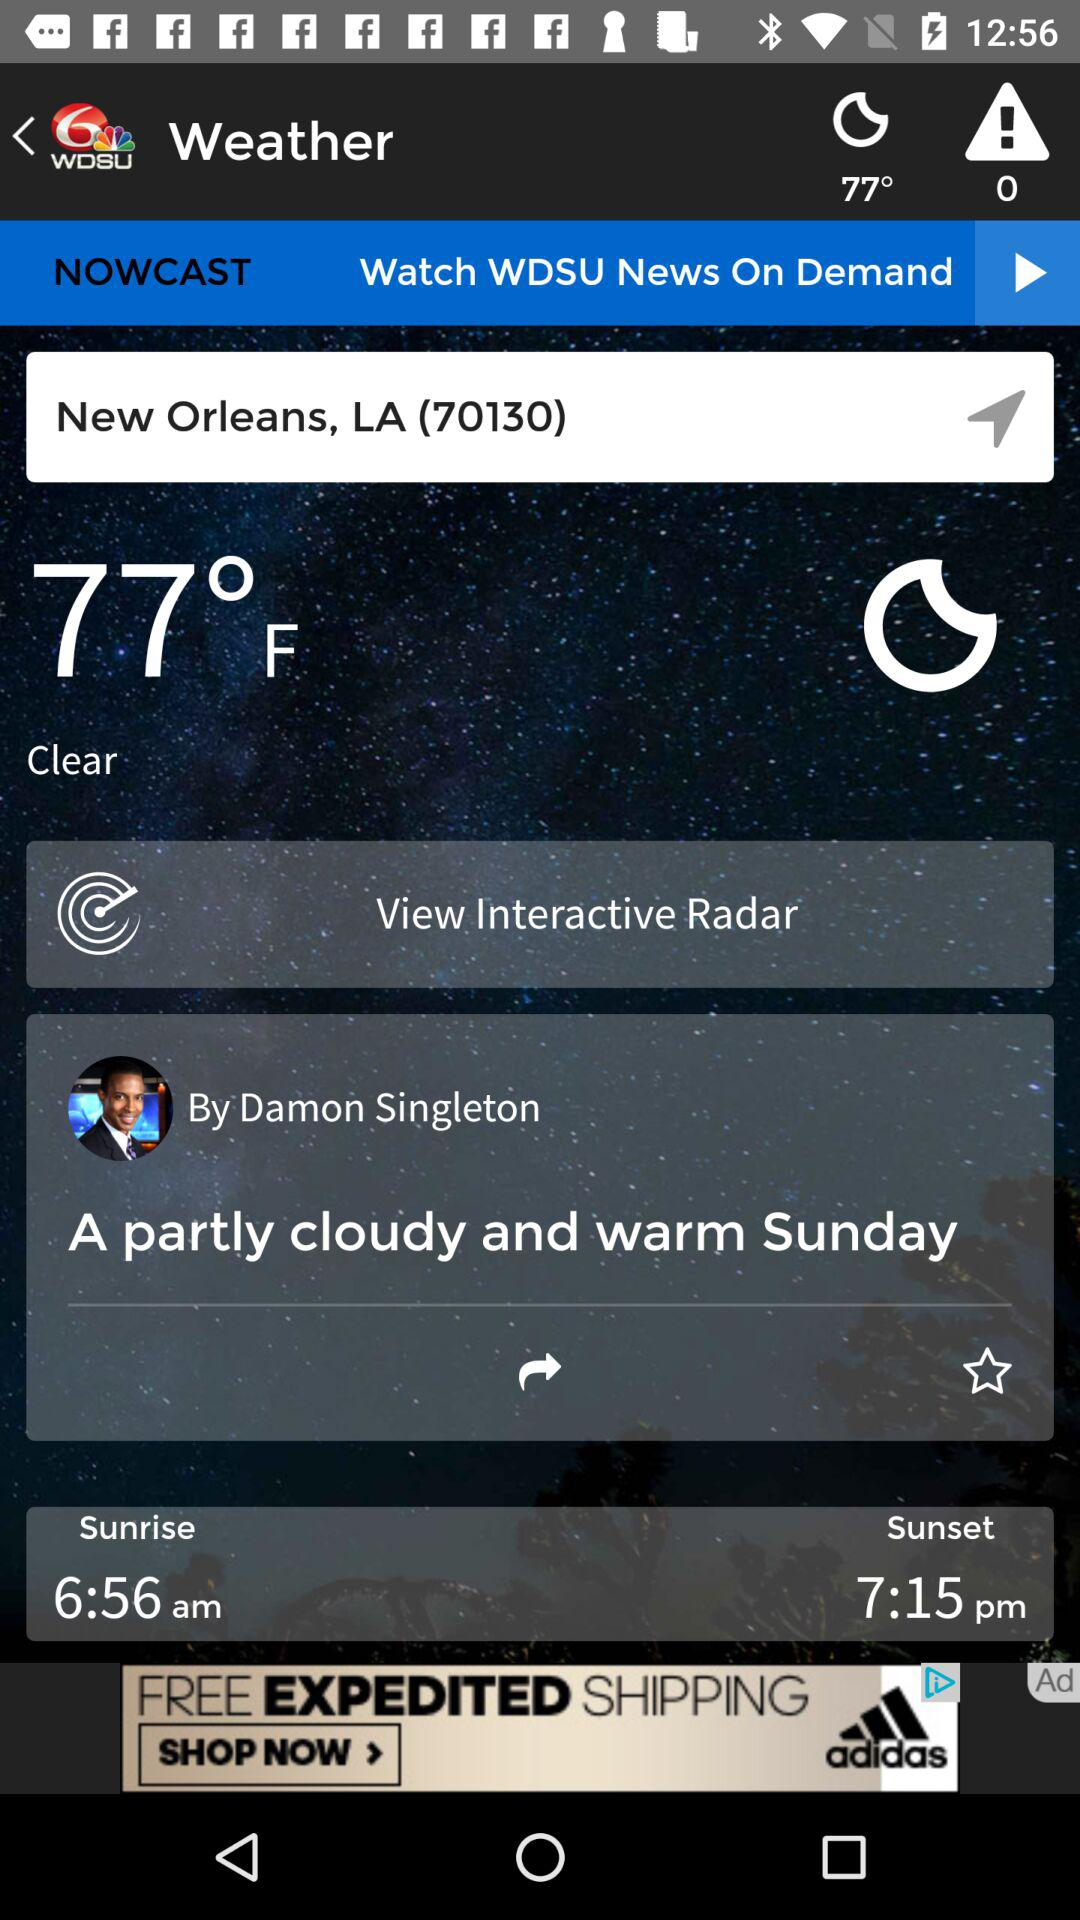What is the time of sunrise? The time of sunrise is 6:56 a.m. 